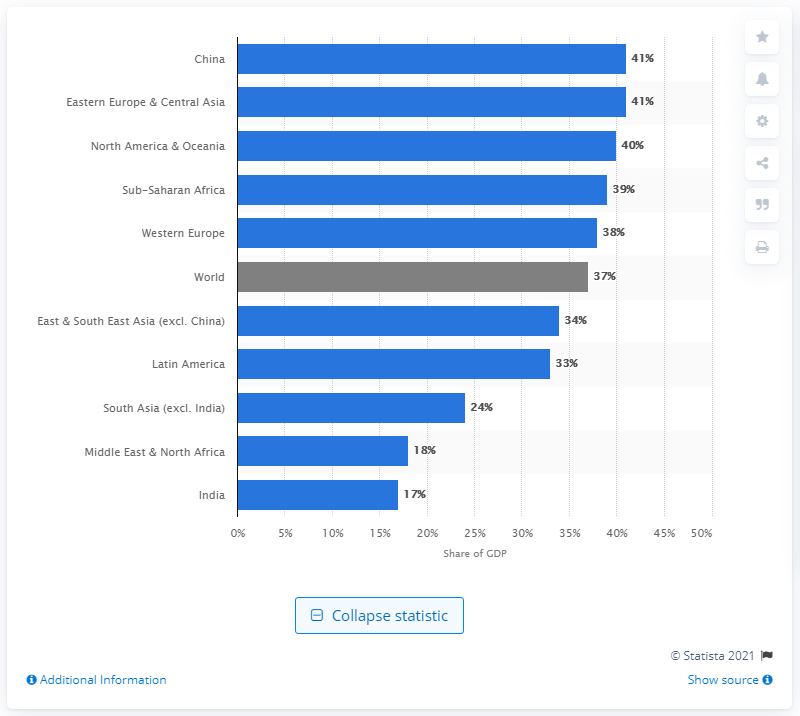Point out several critical features in this image. According to data from 2015, India's female GDP contribution was approximately 17%. 